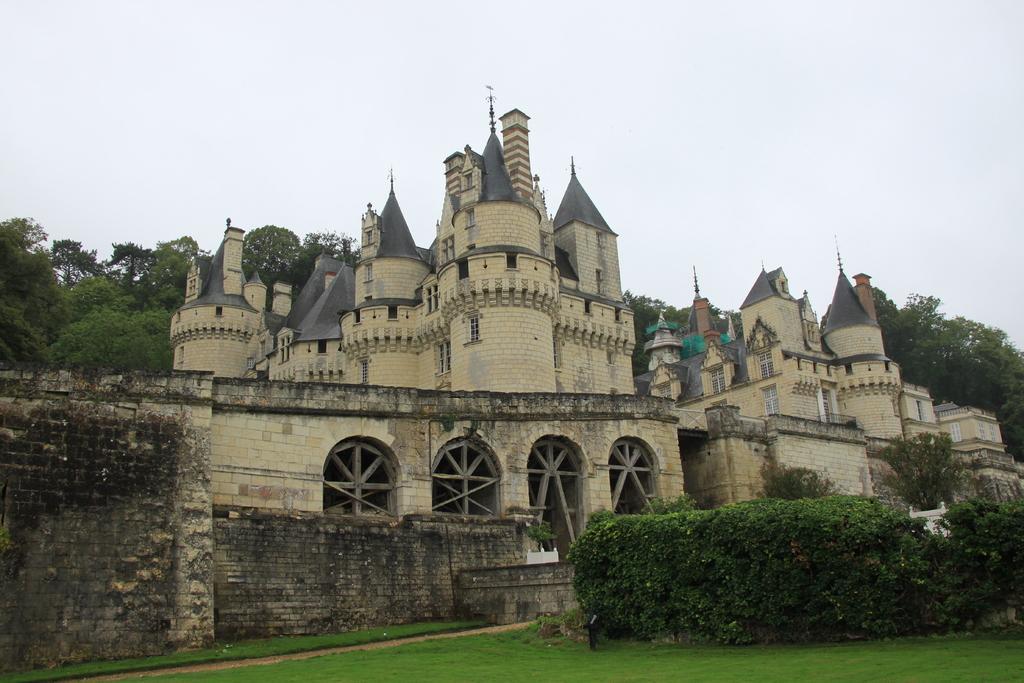Describe this image in one or two sentences. As we can see in the image there are buildings, windows, wall, plants, grass, trees and sky. 